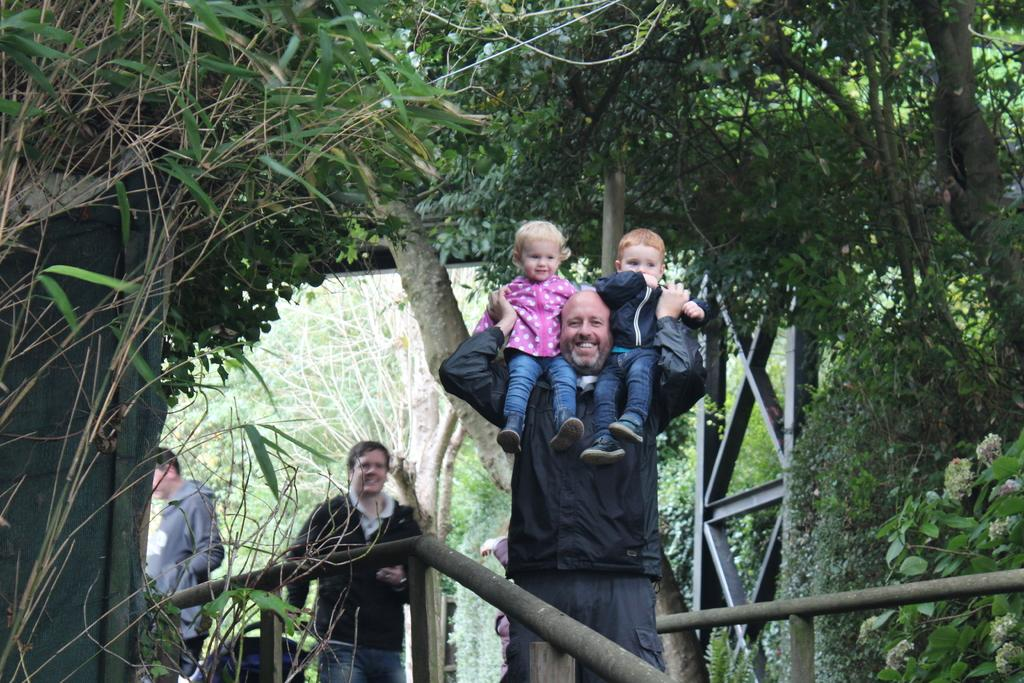How many people are in the image? There are persons in the image. What is one person doing with his hands? One person is holding two kids with his hands. What type of vegetation can be seen in the image? There are plants, flowers, and trees in the image. What is the rate of the beginner crook in the image? There is no crook or any indication of a rate in the image. 